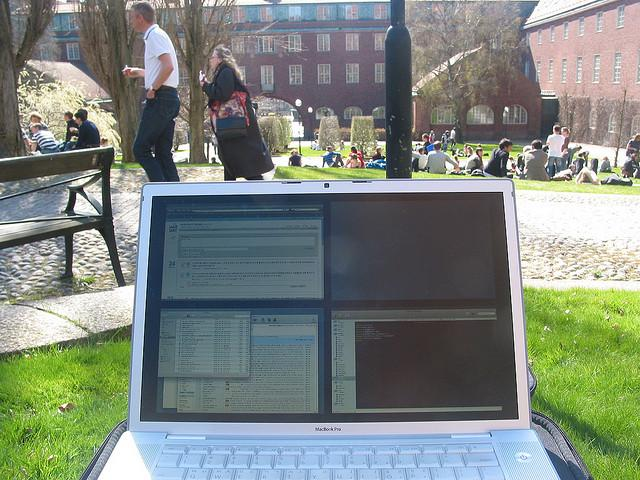Where is this lap top set up? grass 